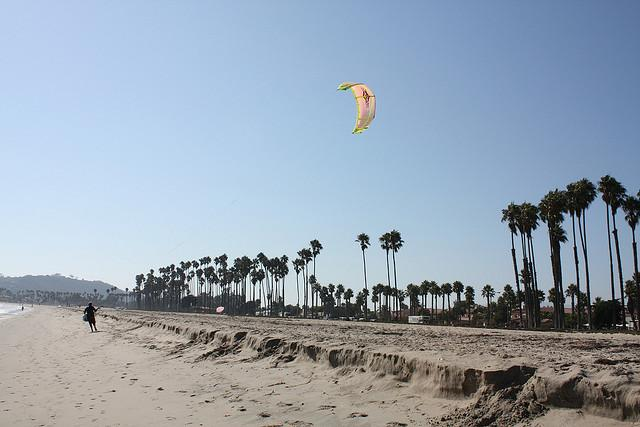What sport can be associated with the above picture? Please explain your reasoning. paragliding. There is a large kite in the air.  kites are used in parasailing. 